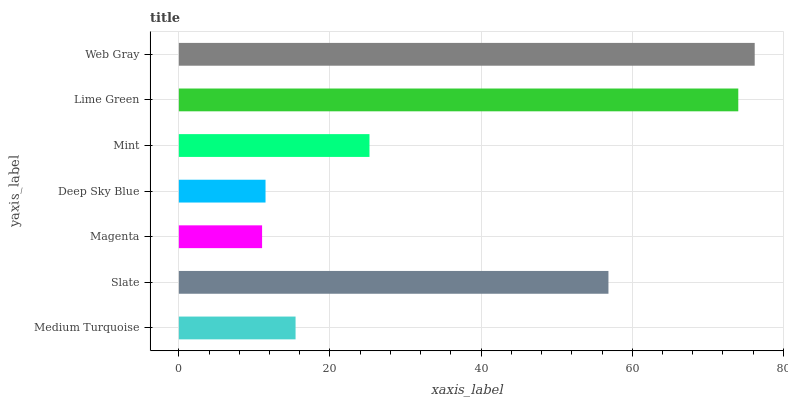Is Magenta the minimum?
Answer yes or no. Yes. Is Web Gray the maximum?
Answer yes or no. Yes. Is Slate the minimum?
Answer yes or no. No. Is Slate the maximum?
Answer yes or no. No. Is Slate greater than Medium Turquoise?
Answer yes or no. Yes. Is Medium Turquoise less than Slate?
Answer yes or no. Yes. Is Medium Turquoise greater than Slate?
Answer yes or no. No. Is Slate less than Medium Turquoise?
Answer yes or no. No. Is Mint the high median?
Answer yes or no. Yes. Is Mint the low median?
Answer yes or no. Yes. Is Slate the high median?
Answer yes or no. No. Is Magenta the low median?
Answer yes or no. No. 